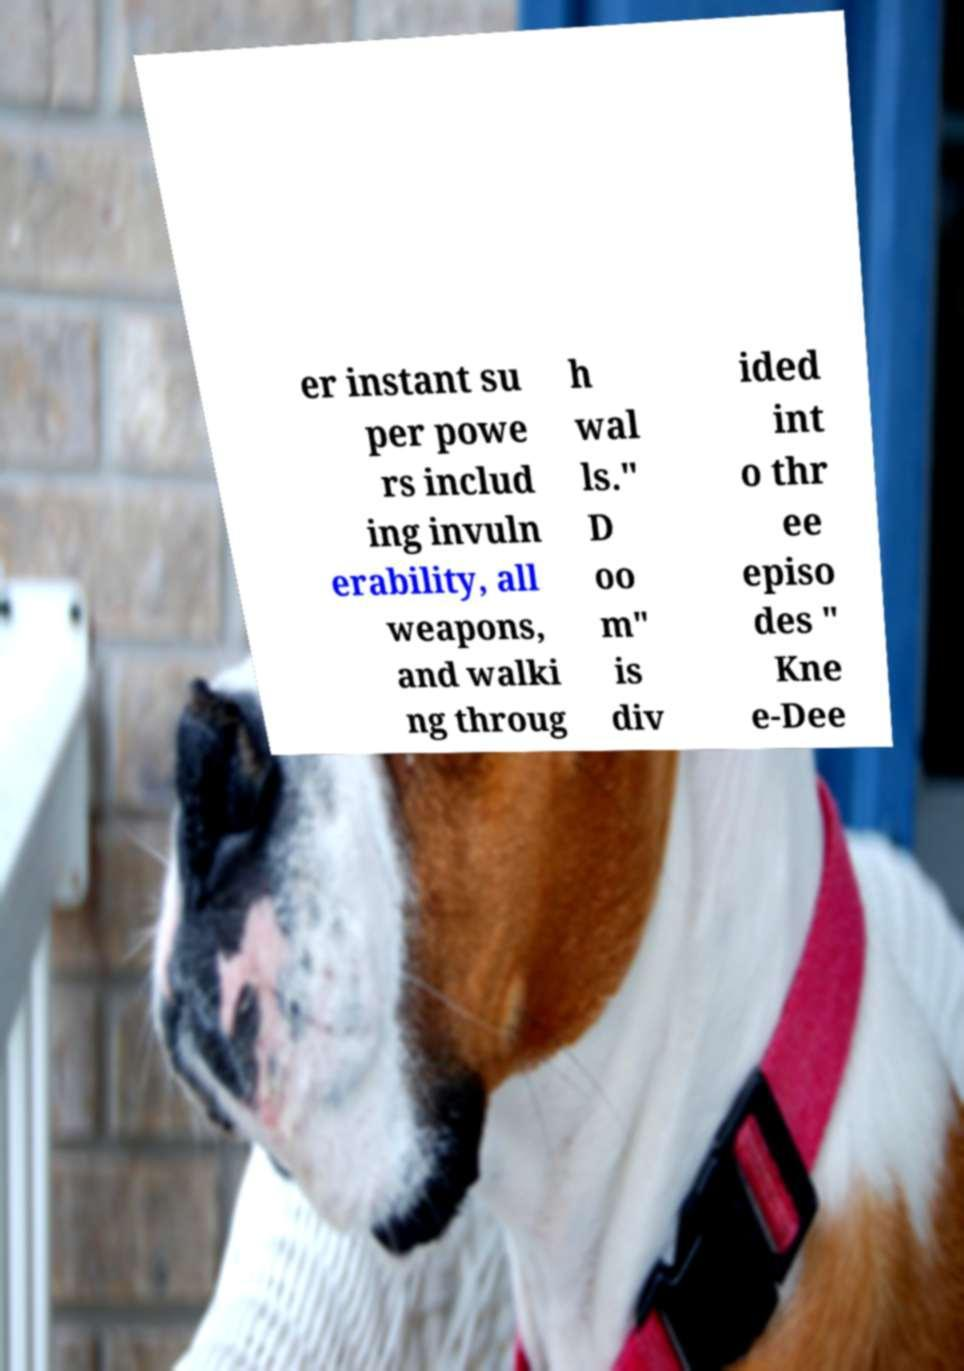Please identify and transcribe the text found in this image. er instant su per powe rs includ ing invuln erability, all weapons, and walki ng throug h wal ls." D oo m" is div ided int o thr ee episo des " Kne e-Dee 